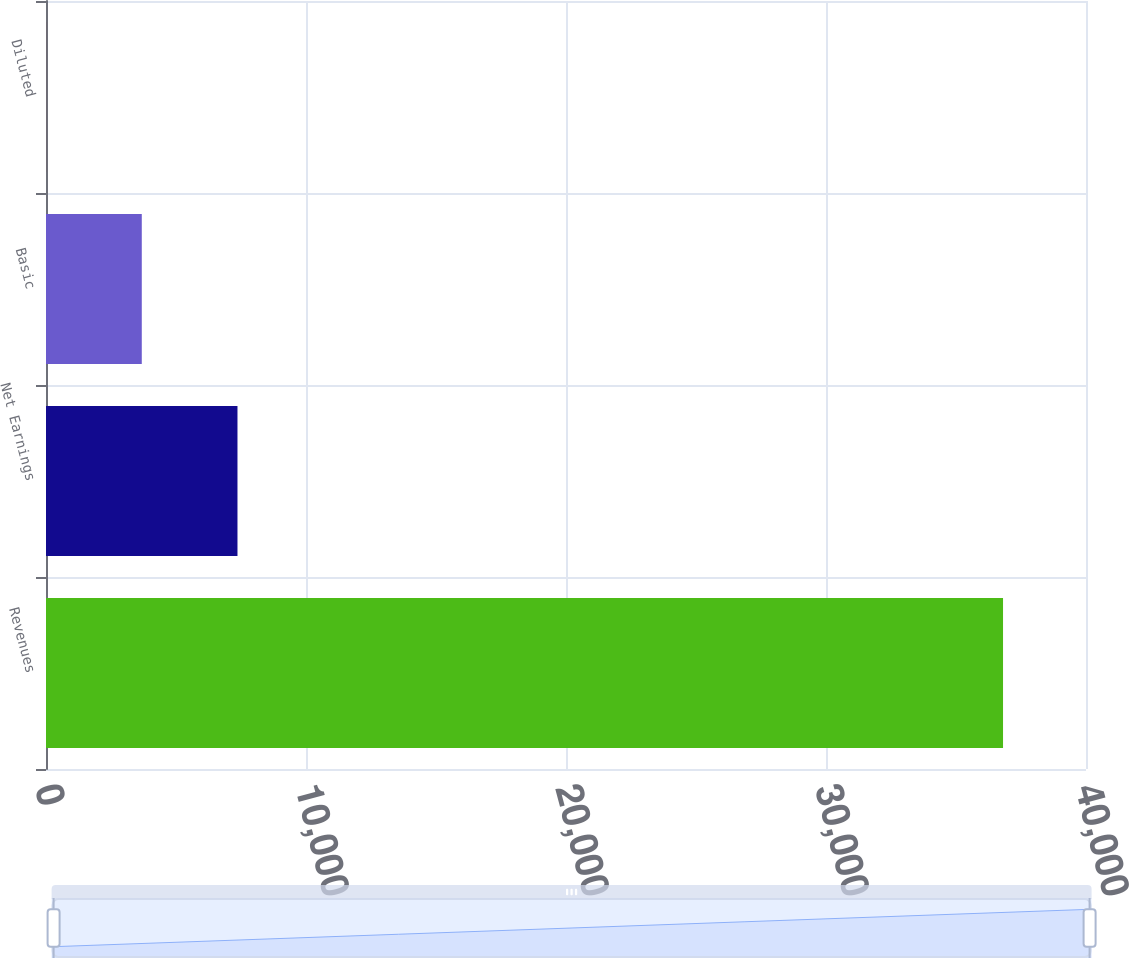Convert chart. <chart><loc_0><loc_0><loc_500><loc_500><bar_chart><fcel>Revenues<fcel>Net Earnings<fcel>Basic<fcel>Diluted<nl><fcel>36809<fcel>7364.35<fcel>3683.77<fcel>3.19<nl></chart> 